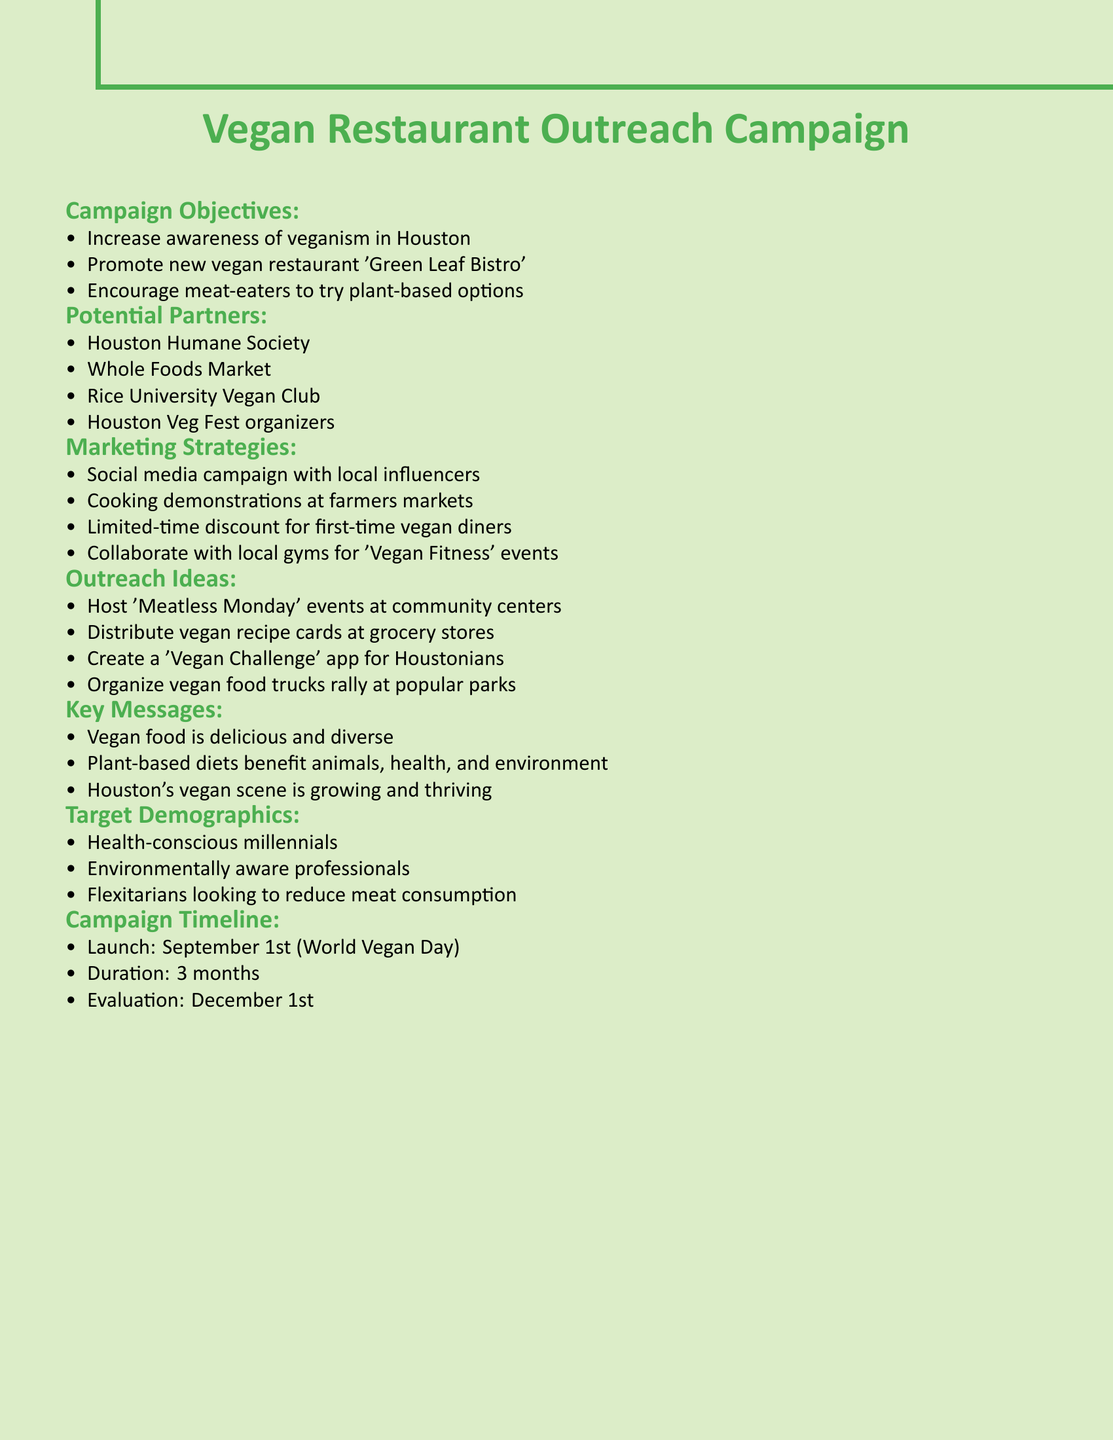What are the campaign objectives? The campaign objectives are listed in a bullet format under the section titled "Campaign Objectives".
Answer: Increase awareness of veganism in Houston, Promote new vegan restaurant 'Green Leaf Bistro', Encourage meat-eaters to try plant-based options Who are the potential partners? Potential partners are listed in the bullet points under "Potential Partners" section.
Answer: Houston Humane Society, Whole Foods Market, Rice University Vegan Club, Houston Veg Fest organizers What is the launch date of the campaign? The launch date is specified in the "Campaign Timeline" section.
Answer: September 1st What is the primary target demographic? The primary target demographic is mentioned under "Target Demographics" and includes health-conscious individuals.
Answer: Health-conscious millennials Which marketing strategy involves local influencers? The marketing strategy that involves local influencers is specified in the "Marketing Strategies" section.
Answer: Social media campaign with local influencers How long will the campaign run? The duration of the campaign is mentioned in the "Campaign Timeline" section.
Answer: 3 months What key message promotes the benefits of plant-based diets? The key messages include several benefits; one is specifically noted in the "Key Messages" section.
Answer: Plant-based diets benefit animals, health, and environment What type of outreach event is suggested for community centers? The outreach event idea is listed in the "Outreach Ideas" section and specifically mentions community centers.
Answer: Host 'Meatless Monday' events at community centers What cooking activity is planned at farmers markets? The planned cooking activity is described under "Marketing Strategies".
Answer: Cooking demonstrations at farmers markets 